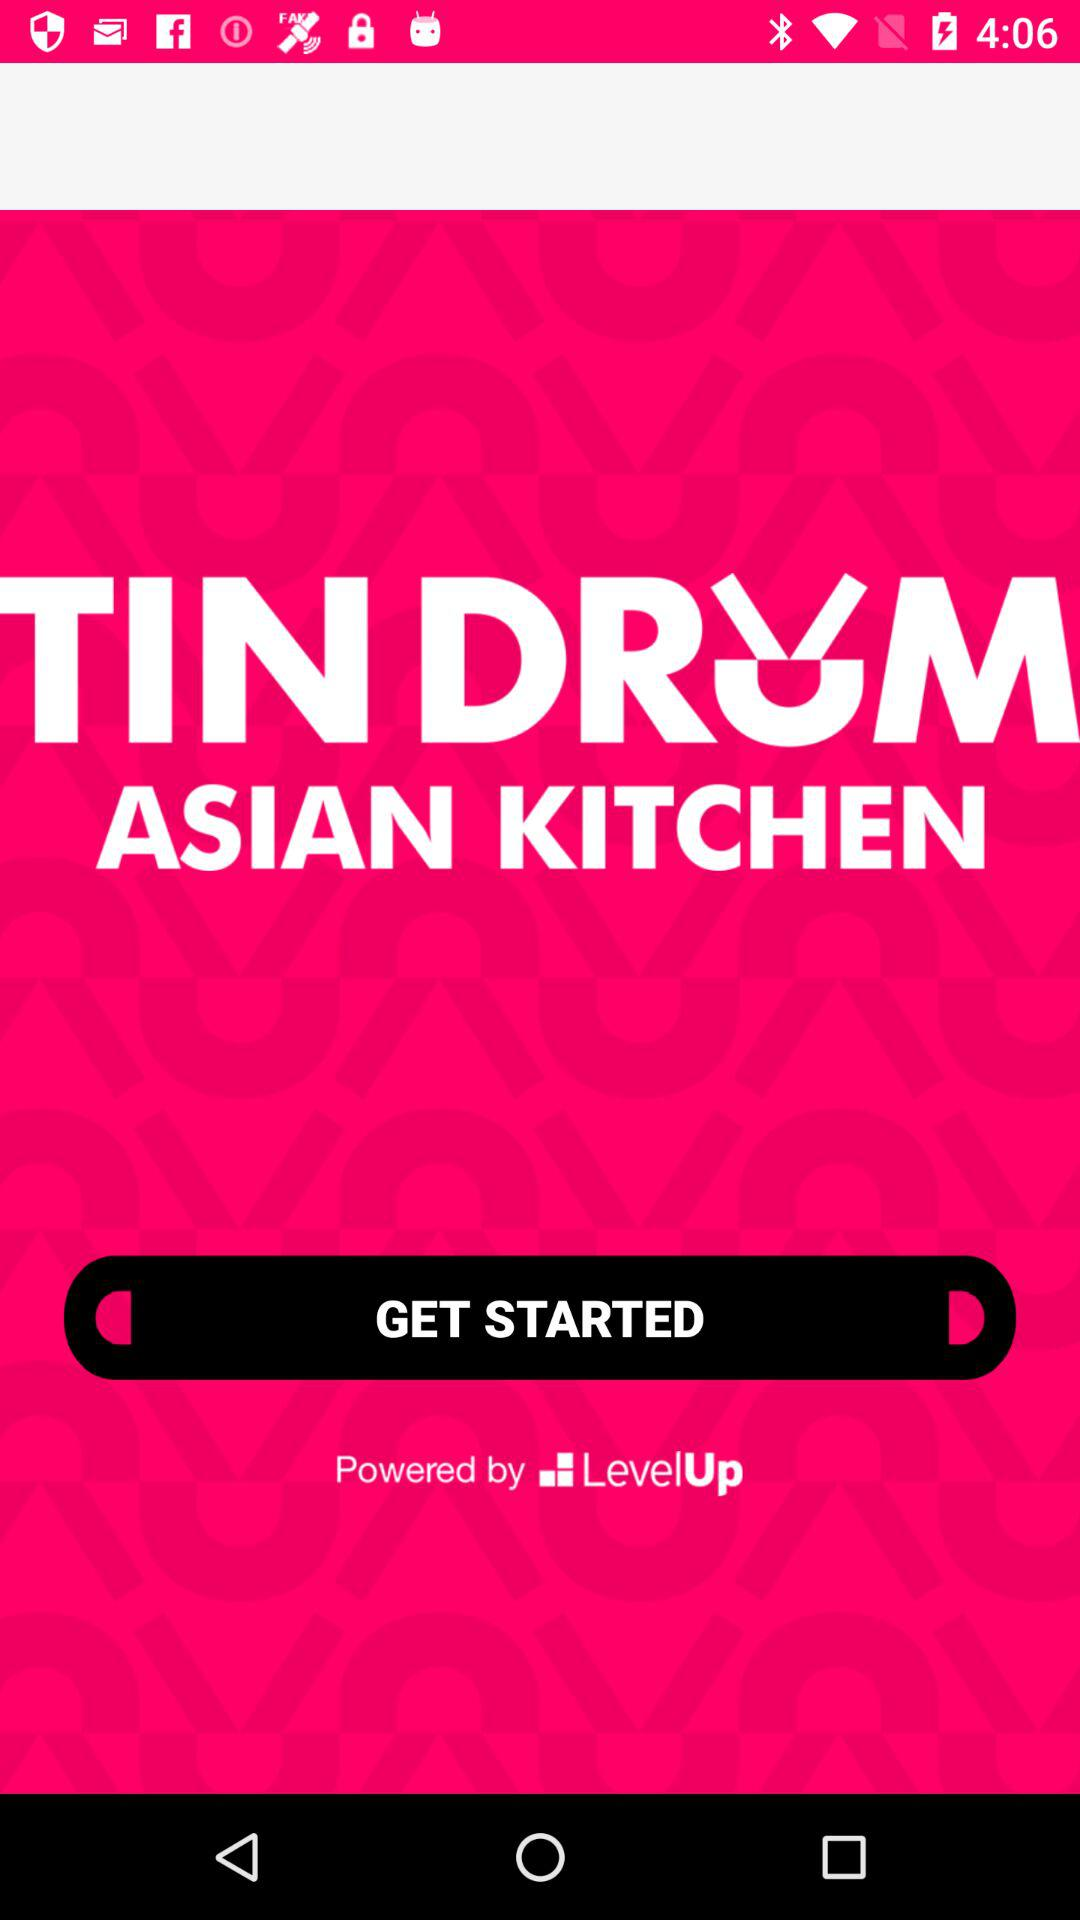What is the name of the application? The name of the application is "TIN DRUM ASIAN KITCHEN". 